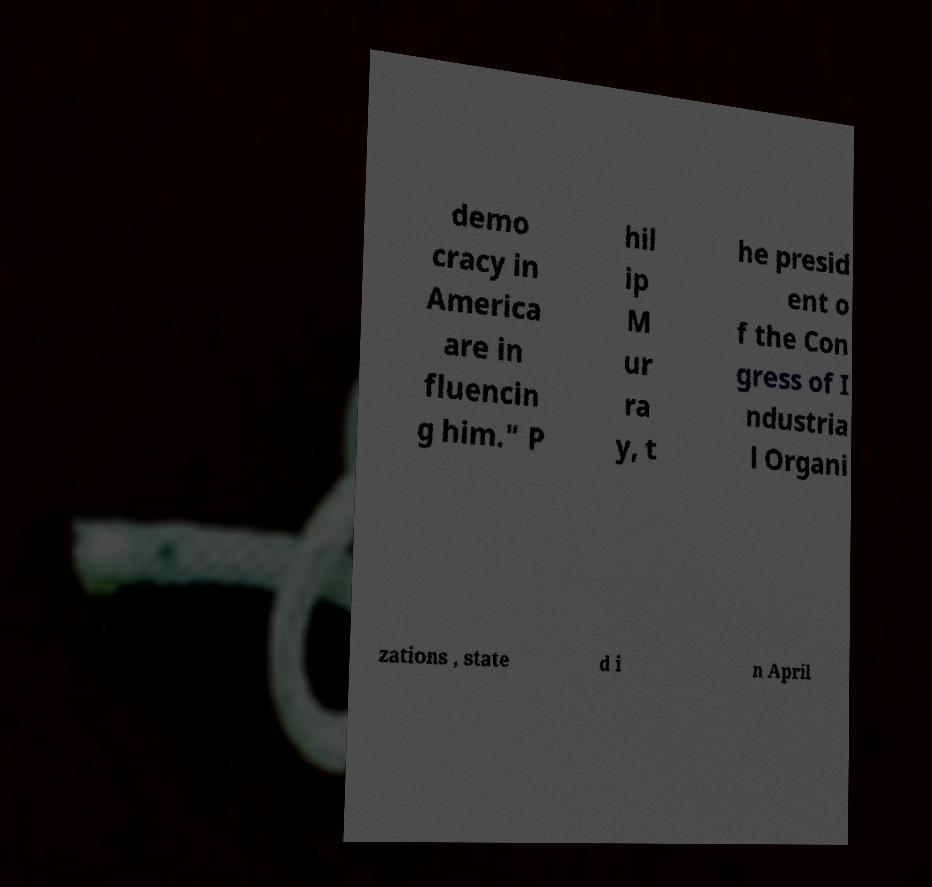Can you accurately transcribe the text from the provided image for me? demo cracy in America are in fluencin g him." P hil ip M ur ra y, t he presid ent o f the Con gress of I ndustria l Organi zations , state d i n April 